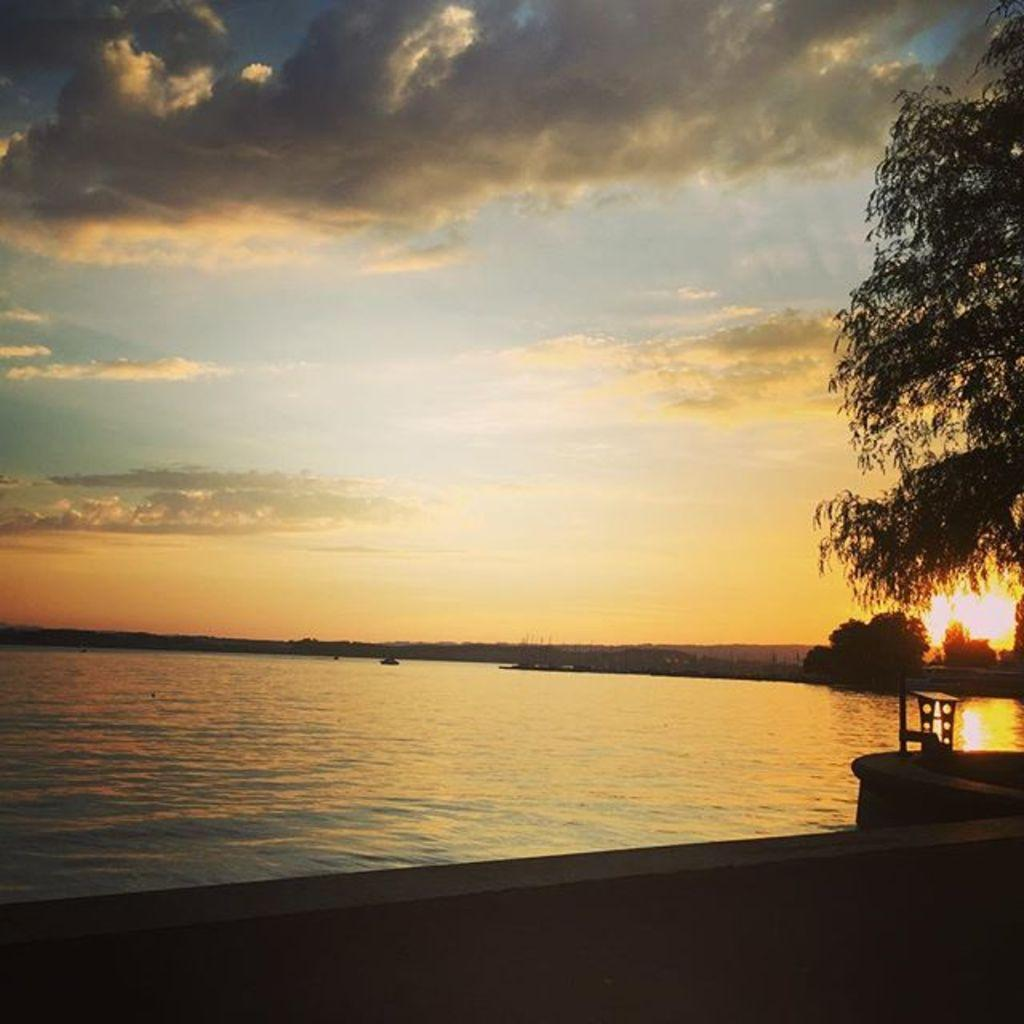What is present in the image that is related to water? There is water in the image. What type of structure can be seen in the image? There is a wall in the image. What is located on the right side of the image? There are trees on the right side of the image. What can be seen on the right side of the image besides the trees? The sun is visible on the right side of the image. What is visible at the top of the image? The sky is visible at the top of the image. What type of cake is being served during the volleyball competition in the image? There is no cake or volleyball competition present in the image. What type of competition is taking place in the image? There is no competition present in the image. 